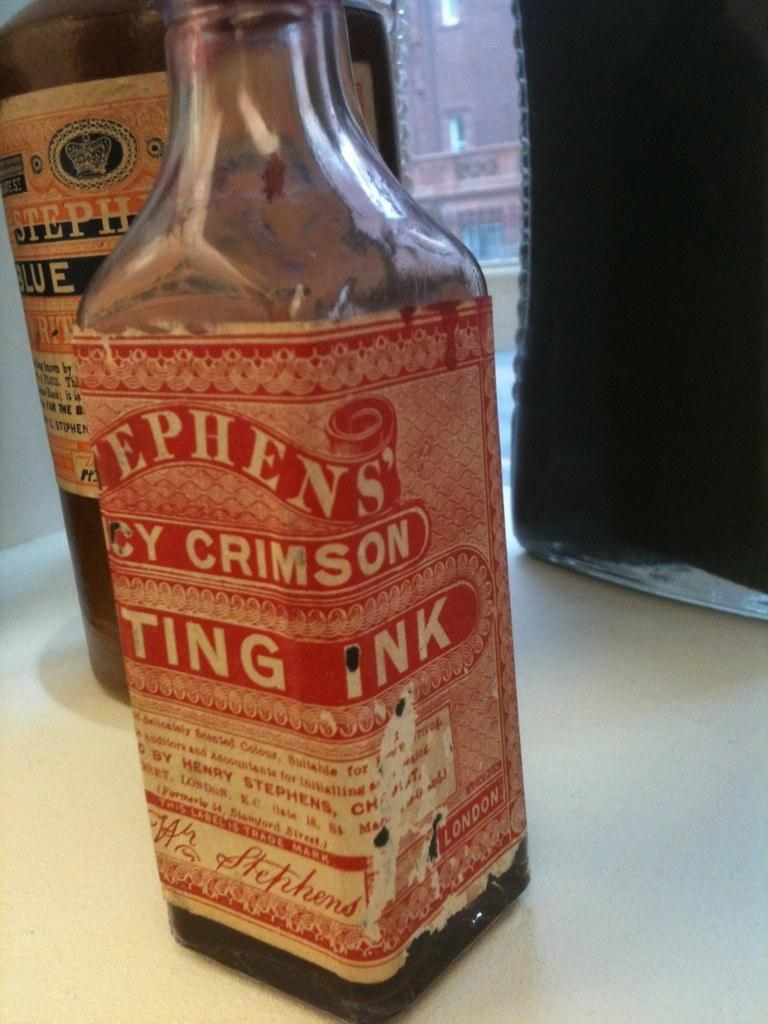<image>
Share a concise interpretation of the image provided. A bottle's label indicates that it contains printing ink inside. 